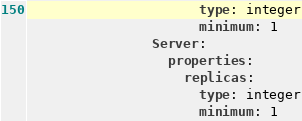Convert code to text. <code><loc_0><loc_0><loc_500><loc_500><_YAML_>                      type: integer
                      minimum: 1
                Server:
                  properties:
                    replicas:
                      type: integer
                      minimum: 1
</code> 